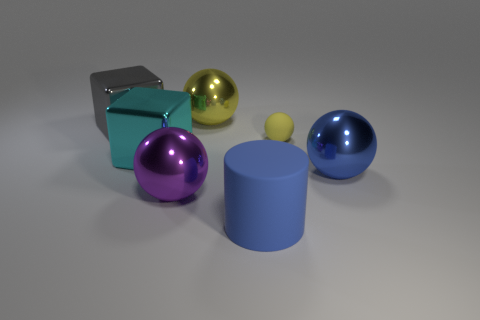What is the shape of the yellow thing that is made of the same material as the large gray block?
Make the answer very short. Sphere. How many cyan objects are either large metallic objects or objects?
Your response must be concise. 1. There is a large ball that is behind the yellow ball right of the yellow shiny sphere; is there a large purple shiny thing behind it?
Keep it short and to the point. No. Are there fewer rubber spheres than large brown shiny objects?
Offer a very short reply. No. There is a cyan object that is in front of the small yellow rubber ball; is its shape the same as the blue metallic object?
Provide a succinct answer. No. Are there any small blue rubber cylinders?
Keep it short and to the point. No. What is the color of the large metallic object that is on the right side of the big matte cylinder in front of the metallic sphere in front of the blue metal thing?
Your response must be concise. Blue. Are there an equal number of purple shiny things behind the small sphere and yellow objects that are in front of the big purple metal ball?
Ensure brevity in your answer.  Yes. What shape is the gray thing that is the same size as the blue matte object?
Offer a terse response. Cube. Are there any rubber spheres of the same color as the rubber cylinder?
Ensure brevity in your answer.  No. 